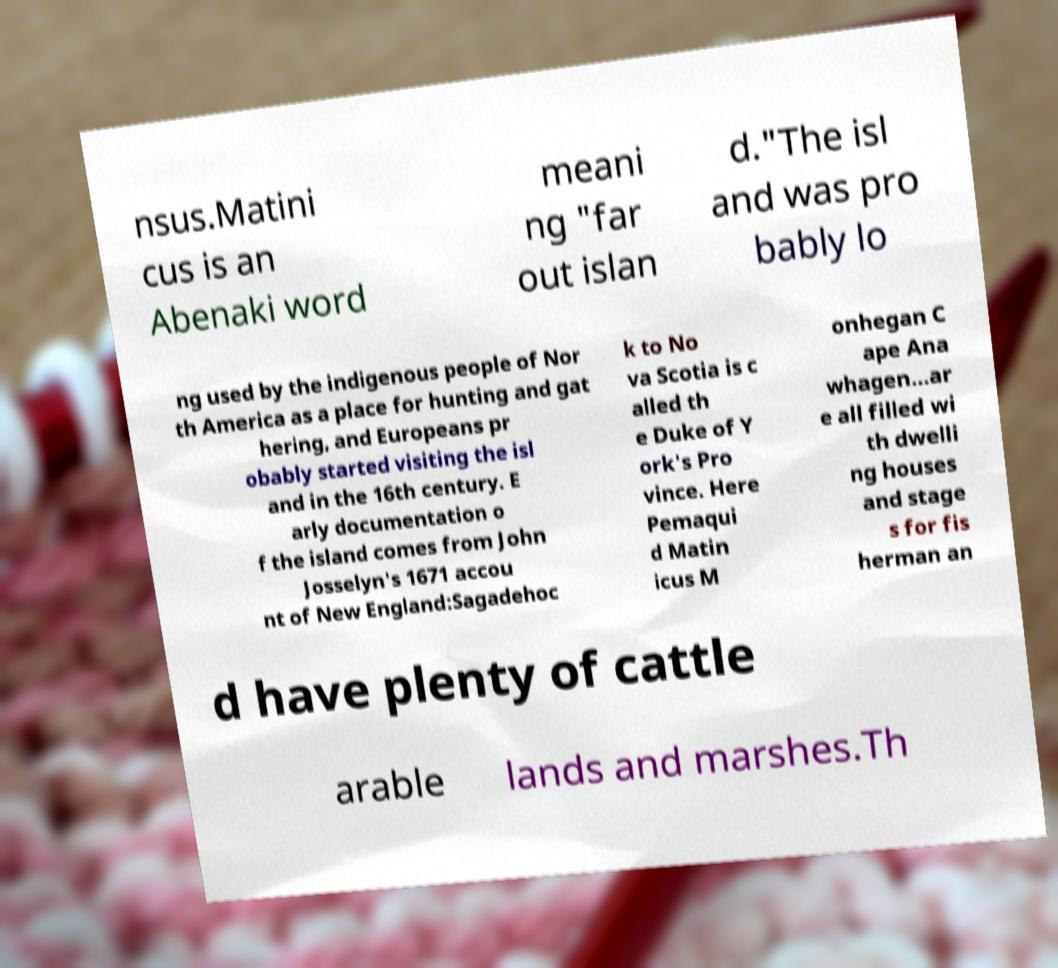Can you read and provide the text displayed in the image?This photo seems to have some interesting text. Can you extract and type it out for me? nsus.Matini cus is an Abenaki word meani ng "far out islan d."The isl and was pro bably lo ng used by the indigenous people of Nor th America as a place for hunting and gat hering, and Europeans pr obably started visiting the isl and in the 16th century. E arly documentation o f the island comes from John Josselyn's 1671 accou nt of New England:Sagadehoc k to No va Scotia is c alled th e Duke of Y ork's Pro vince. Here Pemaqui d Matin icus M onhegan C ape Ana whagen…ar e all filled wi th dwelli ng houses and stage s for fis herman an d have plenty of cattle arable lands and marshes.Th 